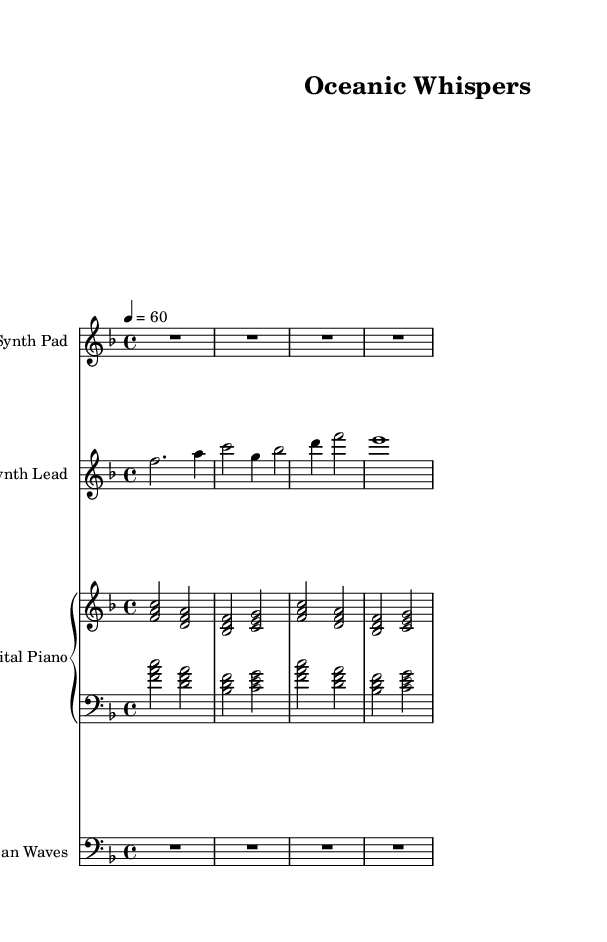What is the key signature of this music? The key signature is identified at the beginning of the staff. It shows one flat (B♭) on the second line, indicating that the piece is in F major.
Answer: F major What is the time signature? The time signature can be found at the beginning of the score, indicating the number of beats per measure. It reads 4/4, meaning there are four beats in each measure and a quarter note receives one beat.
Answer: 4/4 What is the tempo marking given for this piece? The tempo marking is found above the staff, indicated as "4 = 60," which means there are 60 beats per minute, corresponding to quarter note beats.
Answer: 60 How many measures are in the synth lead section? By counting the bars in the synth lead part, we see that there are a total of four measures composed in that section.
Answer: 4 What instruments are indicated in this composition? The score details the different staves with instrument names. The instruments listed are Synth Pad, Synth Lead, Digital Piano, and Ocean Waves.
Answer: Synth Pad, Synth Lead, Digital Piano, Ocean Waves What type of sound is represented by the Ocean Waves staff? The Ocean Waves staff indicates a long rest is used, signifying a continuous sound associated with nature, enhancing the ambient quality of this piece.
Answer: Rest What is the primary musical function of the Digital Piano in this composition? The Digital Piano plays chords that support harmonic rhythm, creating a lush texture that complements the ambient nature of the piece, essential for relaxation.
Answer: Harmony 